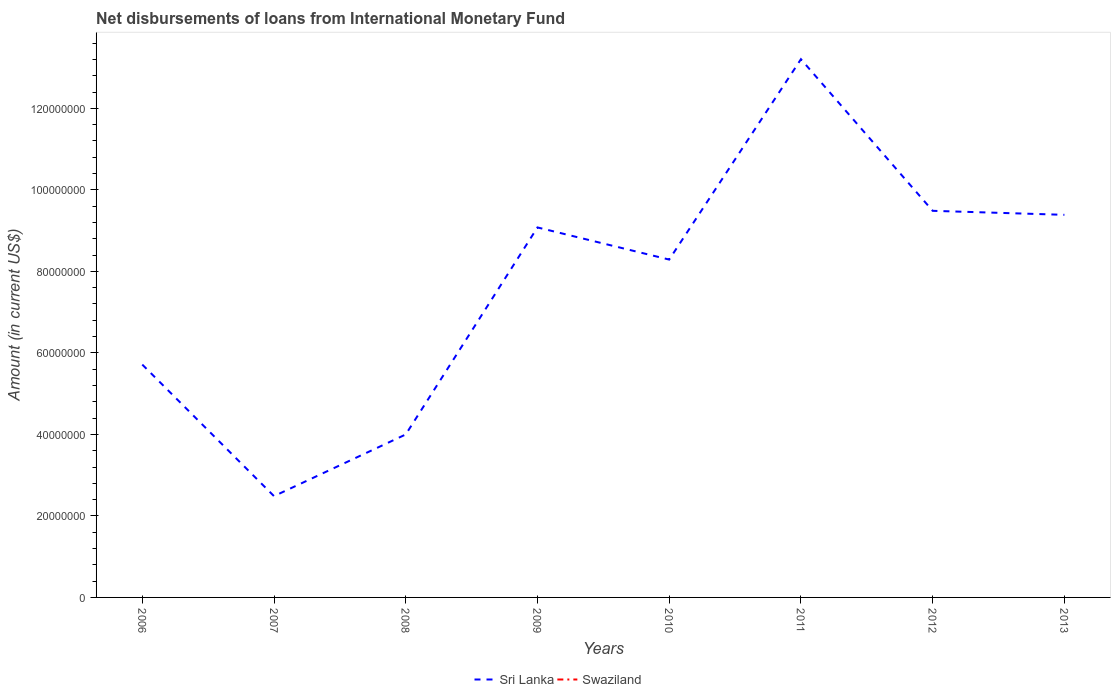Does the line corresponding to Sri Lanka intersect with the line corresponding to Swaziland?
Provide a short and direct response. No. Is the number of lines equal to the number of legend labels?
Provide a short and direct response. No. What is the total amount of loans disbursed in Sri Lanka in the graph?
Provide a succinct answer. -3.67e+07. What is the difference between the highest and the second highest amount of loans disbursed in Sri Lanka?
Keep it short and to the point. 1.07e+08. What is the difference between the highest and the lowest amount of loans disbursed in Sri Lanka?
Give a very brief answer. 5. Is the amount of loans disbursed in Sri Lanka strictly greater than the amount of loans disbursed in Swaziland over the years?
Provide a succinct answer. No. How many years are there in the graph?
Provide a succinct answer. 8. Are the values on the major ticks of Y-axis written in scientific E-notation?
Keep it short and to the point. No. How many legend labels are there?
Make the answer very short. 2. What is the title of the graph?
Give a very brief answer. Net disbursements of loans from International Monetary Fund. Does "Sub-Saharan Africa (developing only)" appear as one of the legend labels in the graph?
Provide a short and direct response. No. What is the Amount (in current US$) of Sri Lanka in 2006?
Provide a succinct answer. 5.71e+07. What is the Amount (in current US$) of Sri Lanka in 2007?
Keep it short and to the point. 2.49e+07. What is the Amount (in current US$) in Swaziland in 2007?
Your answer should be very brief. 0. What is the Amount (in current US$) in Sri Lanka in 2008?
Your answer should be compact. 4.00e+07. What is the Amount (in current US$) of Sri Lanka in 2009?
Offer a very short reply. 9.08e+07. What is the Amount (in current US$) in Swaziland in 2009?
Your answer should be compact. 0. What is the Amount (in current US$) of Sri Lanka in 2010?
Ensure brevity in your answer.  8.29e+07. What is the Amount (in current US$) in Sri Lanka in 2011?
Offer a terse response. 1.32e+08. What is the Amount (in current US$) in Sri Lanka in 2012?
Provide a succinct answer. 9.49e+07. What is the Amount (in current US$) in Sri Lanka in 2013?
Offer a very short reply. 9.39e+07. What is the Amount (in current US$) in Swaziland in 2013?
Ensure brevity in your answer.  0. Across all years, what is the maximum Amount (in current US$) in Sri Lanka?
Offer a very short reply. 1.32e+08. Across all years, what is the minimum Amount (in current US$) of Sri Lanka?
Your response must be concise. 2.49e+07. What is the total Amount (in current US$) of Sri Lanka in the graph?
Provide a short and direct response. 6.16e+08. What is the total Amount (in current US$) of Swaziland in the graph?
Provide a short and direct response. 0. What is the difference between the Amount (in current US$) of Sri Lanka in 2006 and that in 2007?
Your response must be concise. 3.23e+07. What is the difference between the Amount (in current US$) in Sri Lanka in 2006 and that in 2008?
Keep it short and to the point. 1.71e+07. What is the difference between the Amount (in current US$) of Sri Lanka in 2006 and that in 2009?
Offer a very short reply. -3.36e+07. What is the difference between the Amount (in current US$) of Sri Lanka in 2006 and that in 2010?
Offer a very short reply. -2.58e+07. What is the difference between the Amount (in current US$) in Sri Lanka in 2006 and that in 2011?
Provide a short and direct response. -7.49e+07. What is the difference between the Amount (in current US$) in Sri Lanka in 2006 and that in 2012?
Offer a very short reply. -3.77e+07. What is the difference between the Amount (in current US$) of Sri Lanka in 2006 and that in 2013?
Offer a very short reply. -3.67e+07. What is the difference between the Amount (in current US$) of Sri Lanka in 2007 and that in 2008?
Provide a short and direct response. -1.51e+07. What is the difference between the Amount (in current US$) of Sri Lanka in 2007 and that in 2009?
Your answer should be very brief. -6.59e+07. What is the difference between the Amount (in current US$) in Sri Lanka in 2007 and that in 2010?
Ensure brevity in your answer.  -5.80e+07. What is the difference between the Amount (in current US$) in Sri Lanka in 2007 and that in 2011?
Offer a very short reply. -1.07e+08. What is the difference between the Amount (in current US$) of Sri Lanka in 2007 and that in 2012?
Provide a short and direct response. -7.00e+07. What is the difference between the Amount (in current US$) of Sri Lanka in 2007 and that in 2013?
Make the answer very short. -6.90e+07. What is the difference between the Amount (in current US$) in Sri Lanka in 2008 and that in 2009?
Offer a very short reply. -5.08e+07. What is the difference between the Amount (in current US$) in Sri Lanka in 2008 and that in 2010?
Keep it short and to the point. -4.29e+07. What is the difference between the Amount (in current US$) of Sri Lanka in 2008 and that in 2011?
Your answer should be compact. -9.21e+07. What is the difference between the Amount (in current US$) of Sri Lanka in 2008 and that in 2012?
Provide a succinct answer. -5.49e+07. What is the difference between the Amount (in current US$) in Sri Lanka in 2008 and that in 2013?
Offer a very short reply. -5.39e+07. What is the difference between the Amount (in current US$) of Sri Lanka in 2009 and that in 2010?
Give a very brief answer. 7.89e+06. What is the difference between the Amount (in current US$) of Sri Lanka in 2009 and that in 2011?
Your answer should be very brief. -4.13e+07. What is the difference between the Amount (in current US$) of Sri Lanka in 2009 and that in 2012?
Make the answer very short. -4.08e+06. What is the difference between the Amount (in current US$) in Sri Lanka in 2009 and that in 2013?
Ensure brevity in your answer.  -3.09e+06. What is the difference between the Amount (in current US$) of Sri Lanka in 2010 and that in 2011?
Provide a succinct answer. -4.92e+07. What is the difference between the Amount (in current US$) in Sri Lanka in 2010 and that in 2012?
Provide a short and direct response. -1.20e+07. What is the difference between the Amount (in current US$) in Sri Lanka in 2010 and that in 2013?
Offer a very short reply. -1.10e+07. What is the difference between the Amount (in current US$) in Sri Lanka in 2011 and that in 2012?
Provide a short and direct response. 3.72e+07. What is the difference between the Amount (in current US$) in Sri Lanka in 2011 and that in 2013?
Offer a very short reply. 3.82e+07. What is the difference between the Amount (in current US$) of Sri Lanka in 2012 and that in 2013?
Your answer should be compact. 9.83e+05. What is the average Amount (in current US$) in Sri Lanka per year?
Make the answer very short. 7.71e+07. What is the average Amount (in current US$) in Swaziland per year?
Your response must be concise. 0. What is the ratio of the Amount (in current US$) in Sri Lanka in 2006 to that in 2007?
Your answer should be compact. 2.3. What is the ratio of the Amount (in current US$) of Sri Lanka in 2006 to that in 2008?
Provide a short and direct response. 1.43. What is the ratio of the Amount (in current US$) in Sri Lanka in 2006 to that in 2009?
Offer a very short reply. 0.63. What is the ratio of the Amount (in current US$) of Sri Lanka in 2006 to that in 2010?
Your response must be concise. 0.69. What is the ratio of the Amount (in current US$) in Sri Lanka in 2006 to that in 2011?
Provide a short and direct response. 0.43. What is the ratio of the Amount (in current US$) in Sri Lanka in 2006 to that in 2012?
Offer a terse response. 0.6. What is the ratio of the Amount (in current US$) of Sri Lanka in 2006 to that in 2013?
Give a very brief answer. 0.61. What is the ratio of the Amount (in current US$) of Sri Lanka in 2007 to that in 2008?
Ensure brevity in your answer.  0.62. What is the ratio of the Amount (in current US$) of Sri Lanka in 2007 to that in 2009?
Your answer should be very brief. 0.27. What is the ratio of the Amount (in current US$) of Sri Lanka in 2007 to that in 2010?
Provide a short and direct response. 0.3. What is the ratio of the Amount (in current US$) in Sri Lanka in 2007 to that in 2011?
Offer a very short reply. 0.19. What is the ratio of the Amount (in current US$) in Sri Lanka in 2007 to that in 2012?
Give a very brief answer. 0.26. What is the ratio of the Amount (in current US$) in Sri Lanka in 2007 to that in 2013?
Offer a terse response. 0.26. What is the ratio of the Amount (in current US$) of Sri Lanka in 2008 to that in 2009?
Keep it short and to the point. 0.44. What is the ratio of the Amount (in current US$) in Sri Lanka in 2008 to that in 2010?
Your answer should be very brief. 0.48. What is the ratio of the Amount (in current US$) of Sri Lanka in 2008 to that in 2011?
Give a very brief answer. 0.3. What is the ratio of the Amount (in current US$) of Sri Lanka in 2008 to that in 2012?
Provide a short and direct response. 0.42. What is the ratio of the Amount (in current US$) of Sri Lanka in 2008 to that in 2013?
Make the answer very short. 0.43. What is the ratio of the Amount (in current US$) in Sri Lanka in 2009 to that in 2010?
Offer a terse response. 1.1. What is the ratio of the Amount (in current US$) in Sri Lanka in 2009 to that in 2011?
Your response must be concise. 0.69. What is the ratio of the Amount (in current US$) in Sri Lanka in 2009 to that in 2012?
Give a very brief answer. 0.96. What is the ratio of the Amount (in current US$) of Sri Lanka in 2009 to that in 2013?
Offer a very short reply. 0.97. What is the ratio of the Amount (in current US$) of Sri Lanka in 2010 to that in 2011?
Your answer should be very brief. 0.63. What is the ratio of the Amount (in current US$) in Sri Lanka in 2010 to that in 2012?
Your answer should be compact. 0.87. What is the ratio of the Amount (in current US$) in Sri Lanka in 2010 to that in 2013?
Ensure brevity in your answer.  0.88. What is the ratio of the Amount (in current US$) of Sri Lanka in 2011 to that in 2012?
Ensure brevity in your answer.  1.39. What is the ratio of the Amount (in current US$) in Sri Lanka in 2011 to that in 2013?
Keep it short and to the point. 1.41. What is the ratio of the Amount (in current US$) of Sri Lanka in 2012 to that in 2013?
Provide a short and direct response. 1.01. What is the difference between the highest and the second highest Amount (in current US$) of Sri Lanka?
Provide a short and direct response. 3.72e+07. What is the difference between the highest and the lowest Amount (in current US$) in Sri Lanka?
Your answer should be compact. 1.07e+08. 